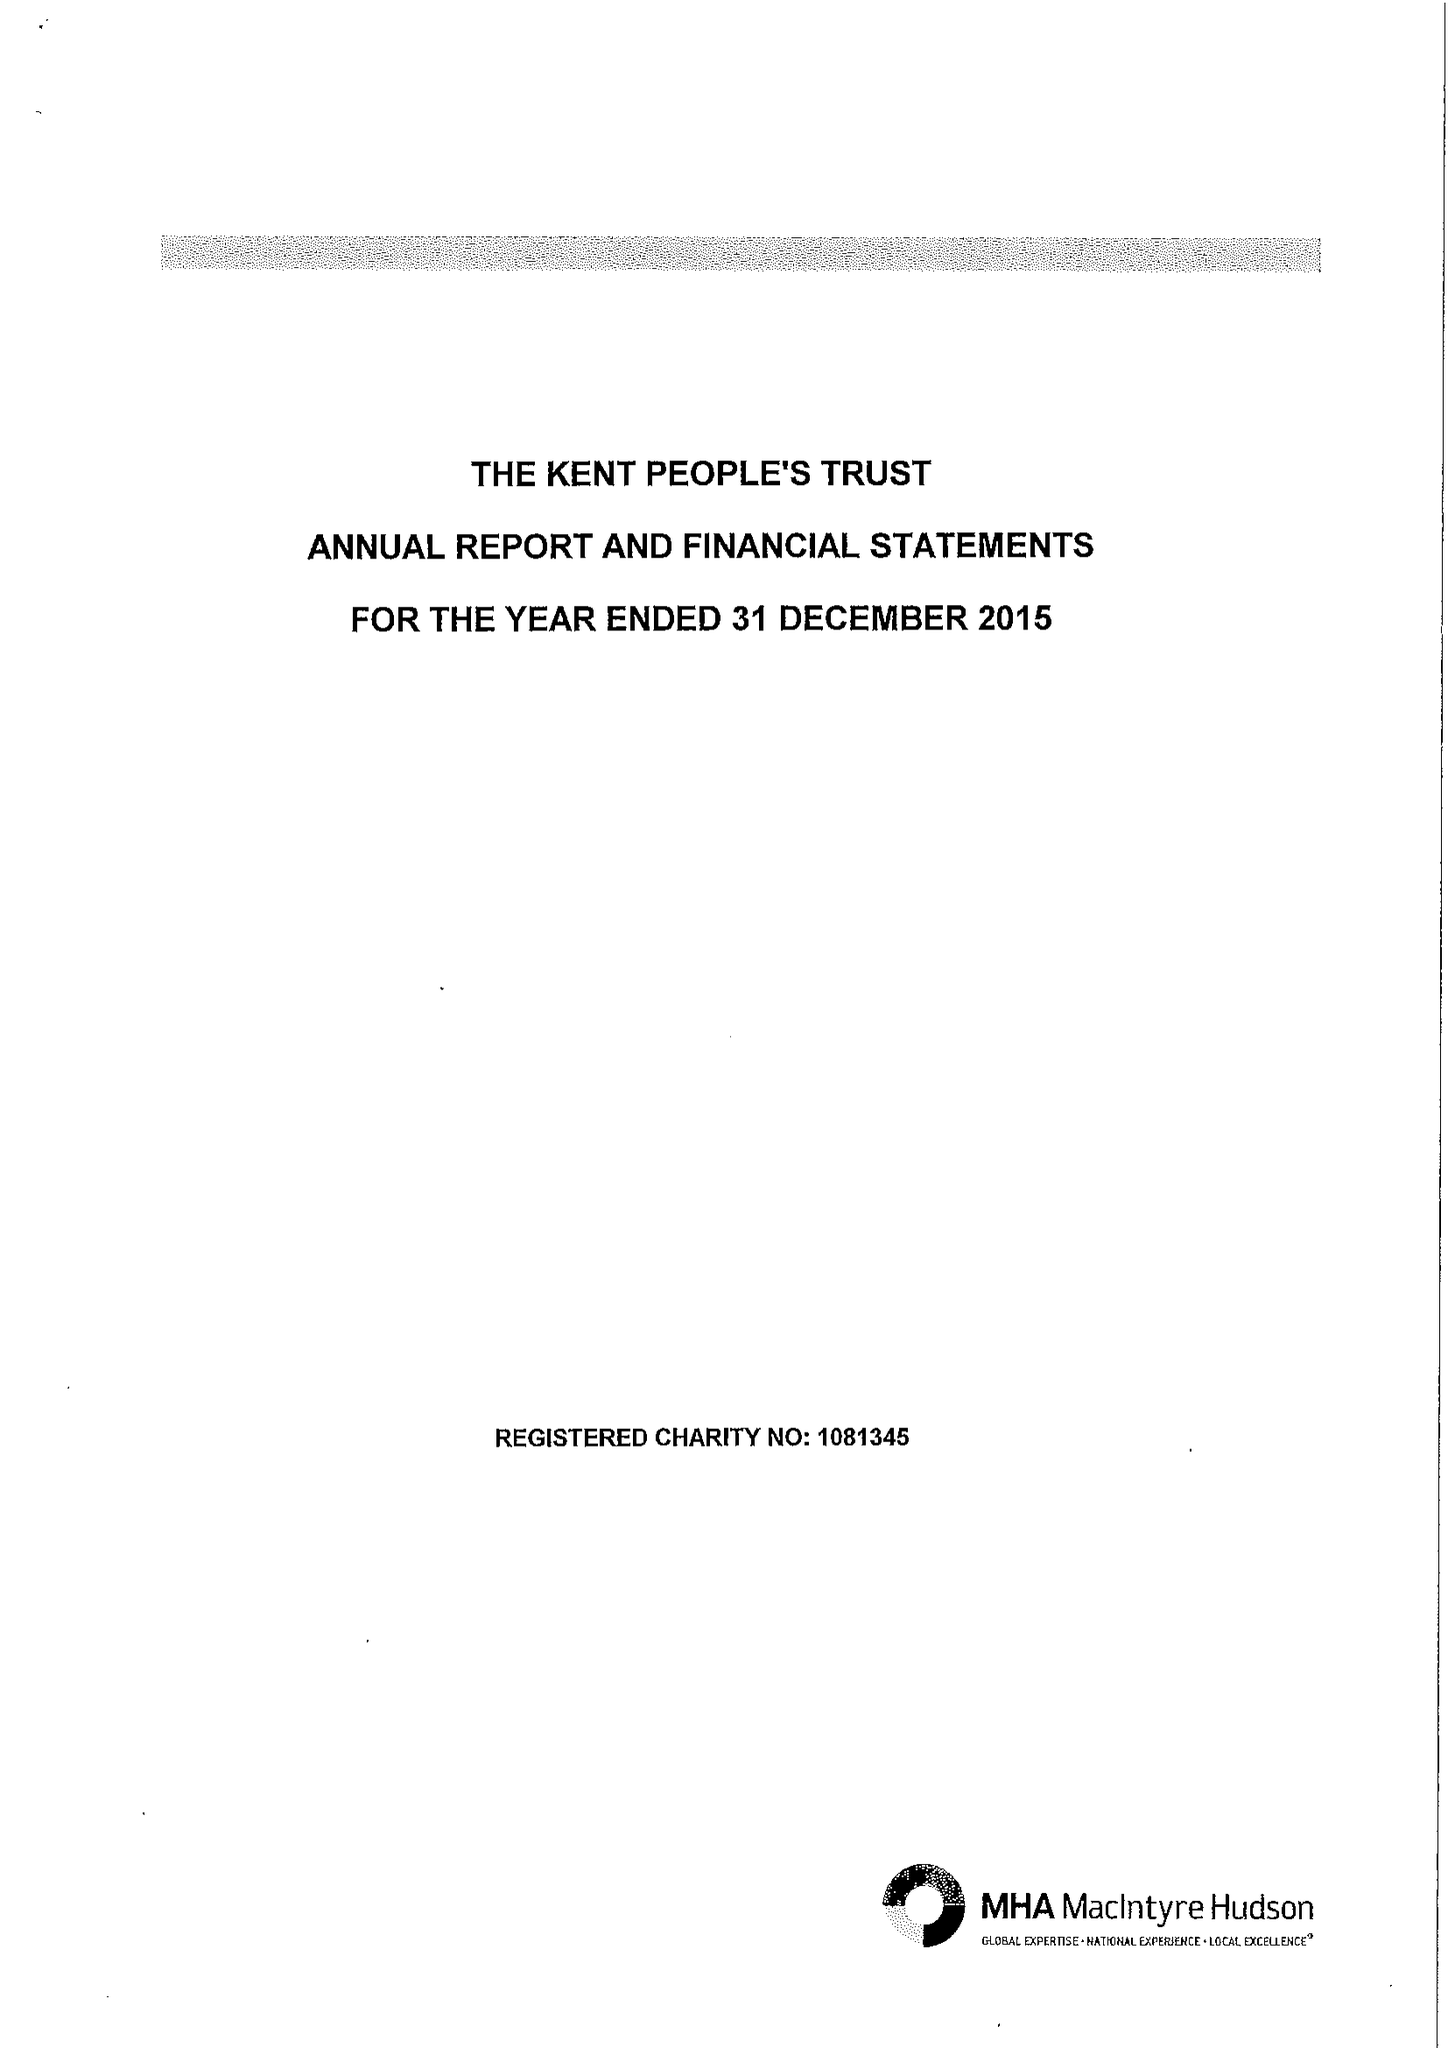What is the value for the address__post_town?
Answer the question using a single word or phrase. MAIDSTONE 